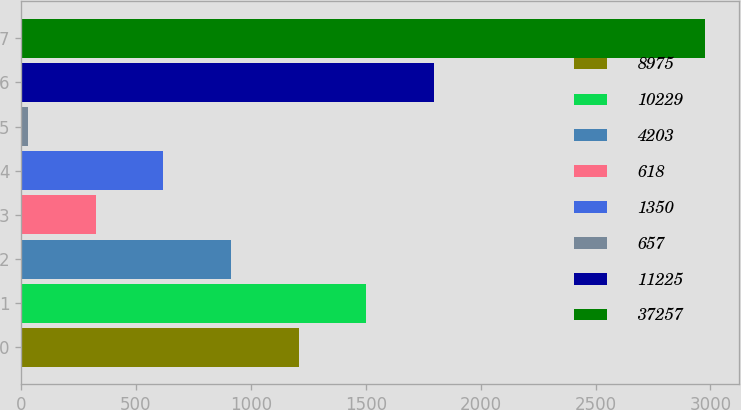<chart> <loc_0><loc_0><loc_500><loc_500><bar_chart><fcel>8975<fcel>10229<fcel>4203<fcel>618<fcel>1350<fcel>657<fcel>11225<fcel>37257<nl><fcel>1207.68<fcel>1502.1<fcel>913.26<fcel>324.42<fcel>618.84<fcel>30<fcel>1796.52<fcel>2974.2<nl></chart> 